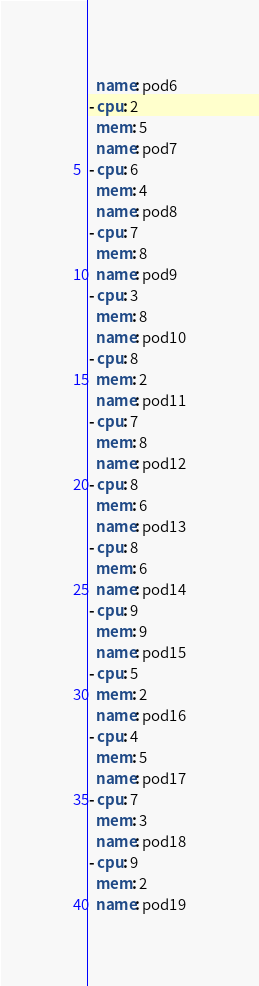Convert code to text. <code><loc_0><loc_0><loc_500><loc_500><_YAML_>  name: pod6
- cpu: 2
  mem: 5
  name: pod7
- cpu: 6
  mem: 4
  name: pod8
- cpu: 7
  mem: 8
  name: pod9
- cpu: 3
  mem: 8
  name: pod10
- cpu: 8
  mem: 2
  name: pod11
- cpu: 7
  mem: 8
  name: pod12
- cpu: 8
  mem: 6
  name: pod13
- cpu: 8
  mem: 6
  name: pod14
- cpu: 9
  mem: 9
  name: pod15
- cpu: 5
  mem: 2
  name: pod16
- cpu: 4
  mem: 5
  name: pod17
- cpu: 7
  mem: 3
  name: pod18
- cpu: 9
  mem: 2
  name: pod19
</code> 